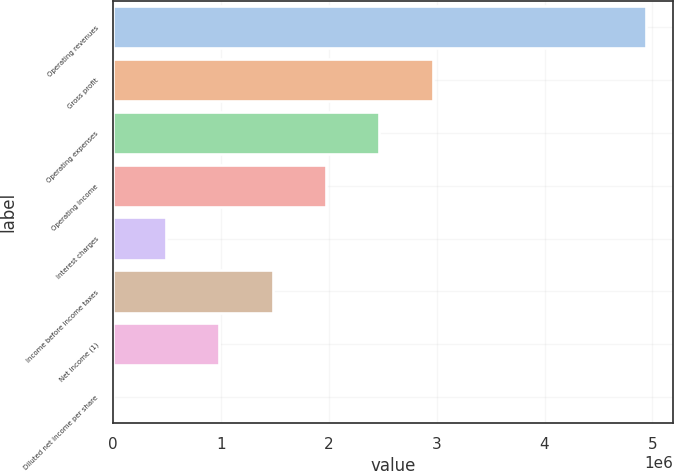<chart> <loc_0><loc_0><loc_500><loc_500><bar_chart><fcel>Operating revenues<fcel>Gross profit<fcel>Operating expenses<fcel>Operating income<fcel>Interest charges<fcel>Income before income taxes<fcel>Net income (1)<fcel>Diluted net income per share<nl><fcel>4.94092e+06<fcel>2.96455e+06<fcel>2.47046e+06<fcel>1.97637e+06<fcel>494094<fcel>1.48228e+06<fcel>988186<fcel>2.96<nl></chart> 